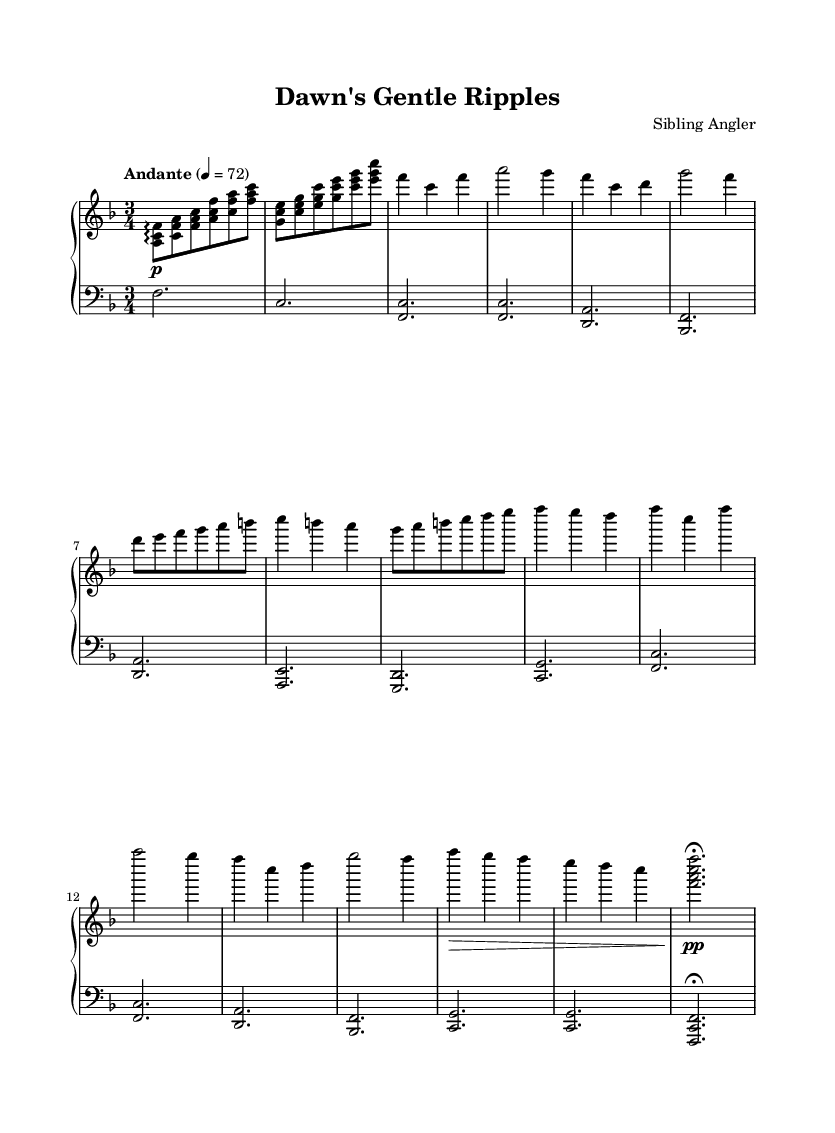What is the key signature of this music? The key signature is F major, which has one flat (B flat). This can be identified by looking at the key signature at the beginning of the staff, which shows one flat.
Answer: F major What is the time signature of this music? The time signature is 3/4, indicating three beats per measure and a quarter note receives one beat. This is visible at the beginning of the piece where the time signature is written.
Answer: 3/4 What is the tempo marking given for this piece? The tempo marking is "Andante," which indicates a moderate tempo. This is found at the beginning of the score, right before the first measure.
Answer: Andante How many measures are in the A section? The A section consists of four measures, as counted visually from the sheet music where the A section begins and ends.
Answer: 4 What dynamic marking is found in the Coda? The dynamic marking in the Coda is "pp," which stands for pianissimo, indicating very soft playing. This can be seen in the last section of the piece, right before the final note.
Answer: pp What is the range of the piano used in this piece? The piano covers a range from F2 in the left hand to A6 in the right hand. This can be determined by observing the lowest and highest notes played in both staves throughout the music.
Answer: F2 to A6 How does the B section contrast with the A section? The B section introduces sixteenth notes and moves through a more melodic sequence compared to the A section's chordal texture, creating a sense of development. This can be understood by analyzing the figuration and rhythmic structure between the two sections.
Answer: Different texture 